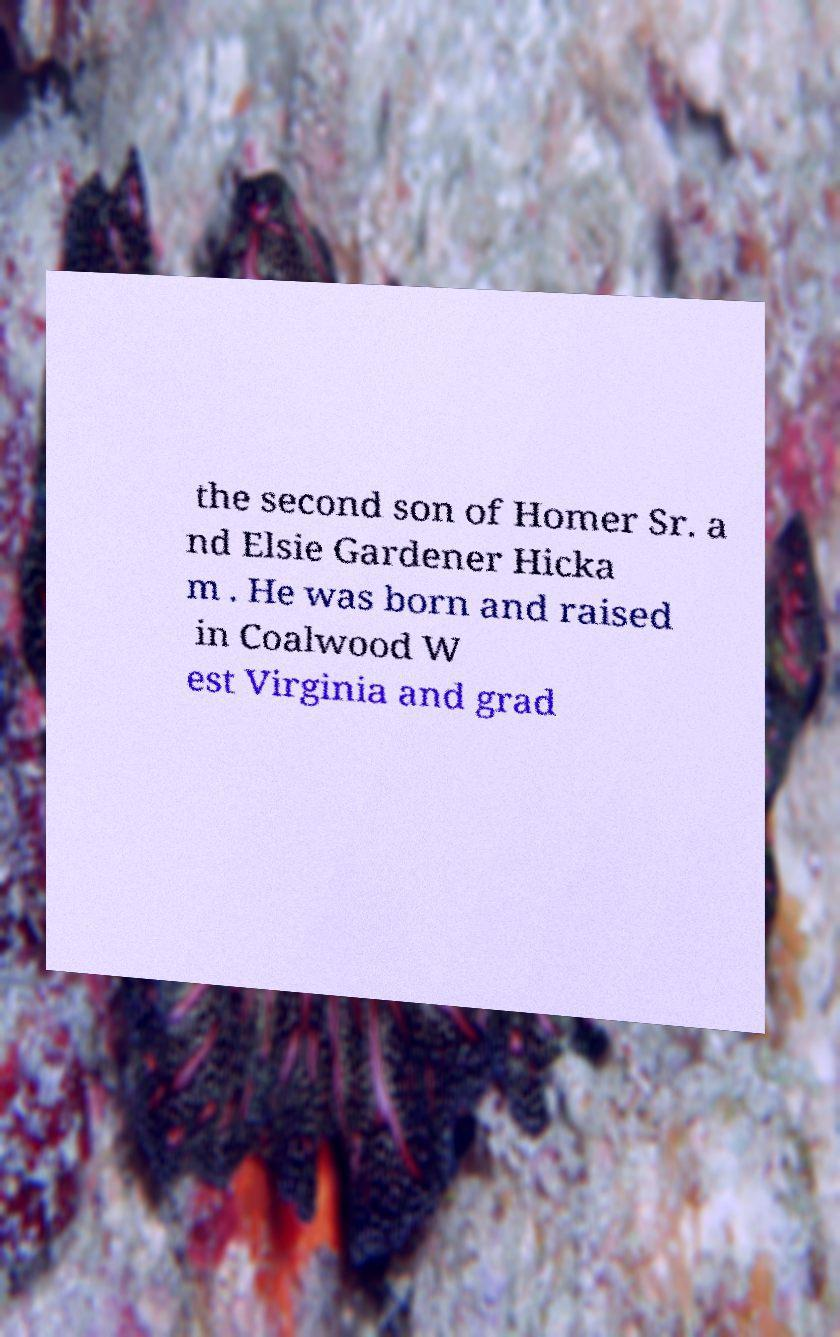I need the written content from this picture converted into text. Can you do that? the second son of Homer Sr. a nd Elsie Gardener Hicka m . He was born and raised in Coalwood W est Virginia and grad 